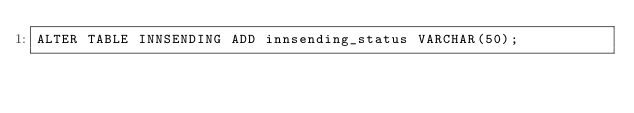Convert code to text. <code><loc_0><loc_0><loc_500><loc_500><_SQL_>ALTER TABLE INNSENDING ADD innsending_status VARCHAR(50);</code> 